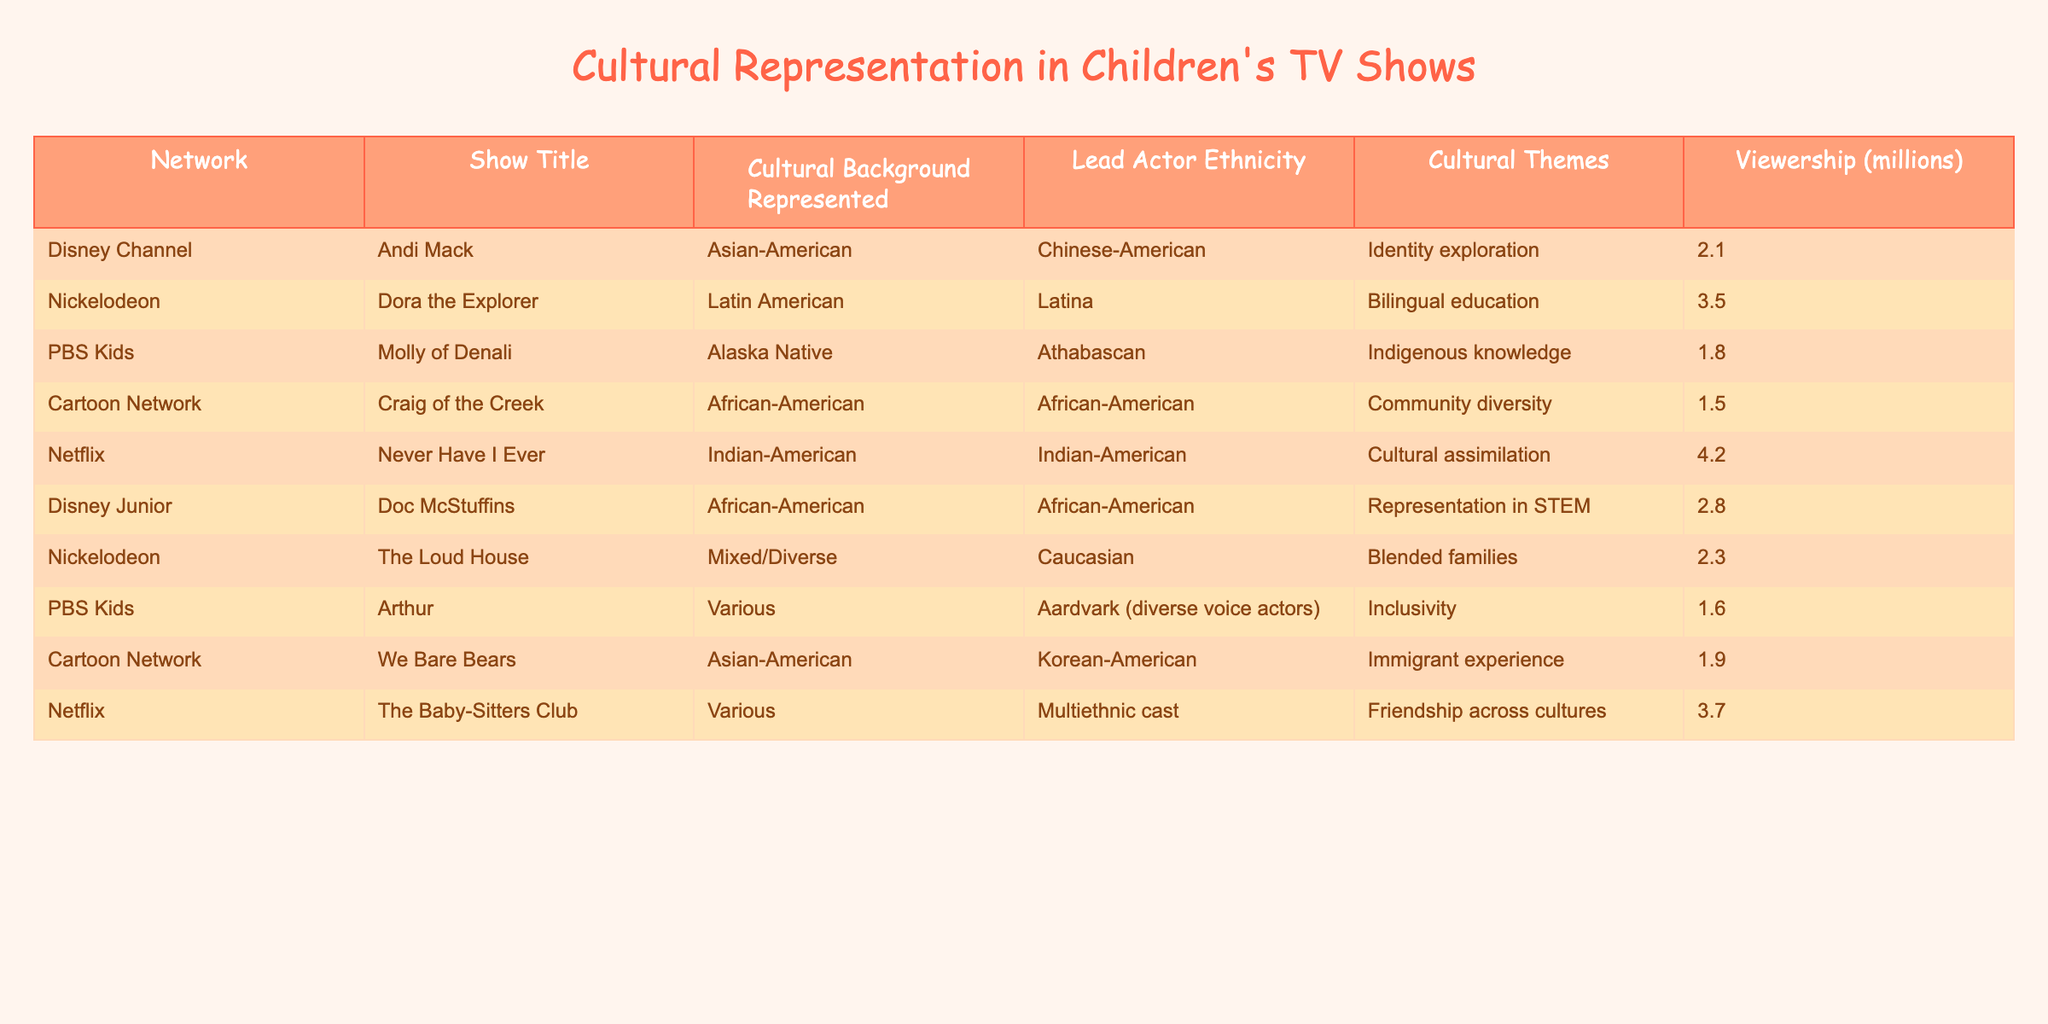What is the cultural background represented in "Andi Mack"? The table lists "Andi Mack" under the Disney Channel, showing that it represents the Asian-American cultural background.
Answer: Asian-American Which show on Nickelodeon has the highest viewership? By comparing the viewership numbers, "Dora the Explorer" has 3.5 million viewers, making it the highest on Nickelodeon.
Answer: Dora the Explorer How many shows represent African-American culture, and what are their titles? The table indicates two shows that represent African-American culture: "Craig of the Creek" and "Doc McStuffins."
Answer: 2 shows: Craig of the Creek, Doc McStuffins What is the average viewership of the shows listed on PBS Kids? Adding the viewership of "Molly of Denali" (1.8 million) and "Arthur" (1.6 million) gives 3.4 million. Dividing by 2 shows results in an average of 1.7 million.
Answer: 1.7 million Is "Molly of Denali" more representative of a specific cultural background than "Arthur"? Yes, "Molly of Denali" represents the Alaska Native cultural background, while "Arthur" represents various cultures with a diverse voice cast.
Answer: Yes Which platform has the most shows representing a variety of cultural backgrounds? By analyzing the table, Netflix features the most diverse shows with multiethnic representation in "The Baby-Sitters Club" and "Never Have I Ever."
Answer: Netflix What is the total viewership of all the shows represented in the table? Summing the viewership numbers of all shows gives (2.1 + 3.5 + 1.8 + 1.5 + 4.2 + 2.8 + 2.3 + 1.6 + 1.9 + 3.7) = 23.4 million.
Answer: 23.4 million What unique cultural theme is represented by "Never Have I Ever"? The show "Never Have I Ever" addresses the theme of cultural assimilation in the context of being Indian-American.
Answer: Cultural assimilation Which show has a lead actor of Asian-American descent and what cultural theme does it represent? The show "We Bare Bears" features a Korean-American lead actor and represents the immigrant experience as its cultural theme.
Answer: We Bare Bears, immigrant experience Does "The Loud House" have a single cultural background represented? No, "The Loud House" represents mixed/diverse backgrounds, indicating a blend of various cultures.
Answer: No 